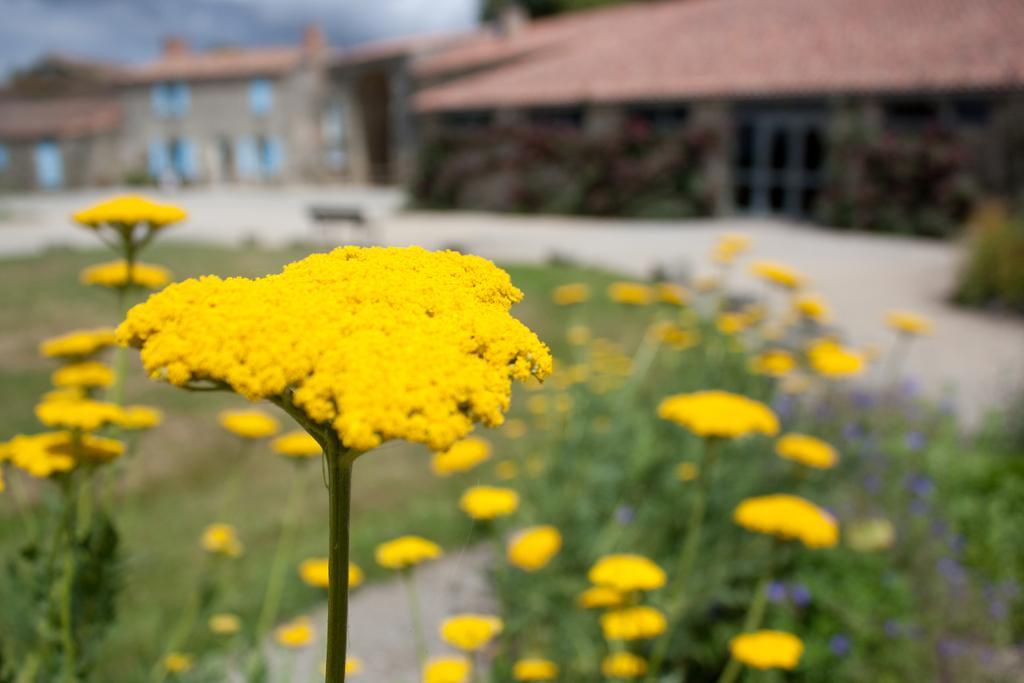Describe this image in one or two sentences. In this picture I can observe yellow color flowers to the plants. In the background there are houses and I can observe sky. 